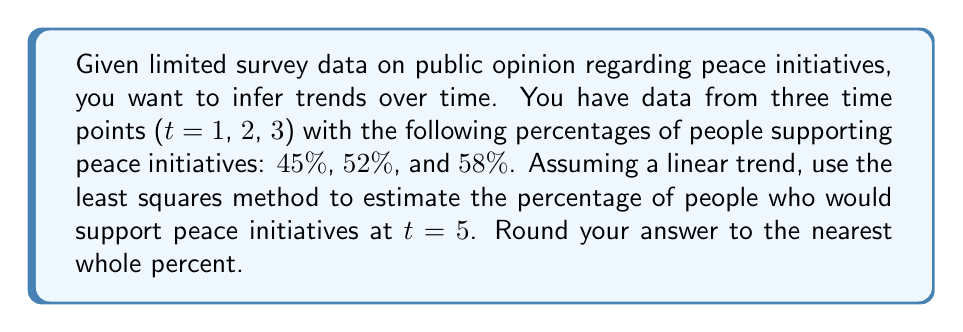Can you answer this question? To solve this inverse problem and infer the trend in public opinion, we'll use the least squares method to fit a linear model to the data.

Step 1: Set up the linear model
Let $y = mx + b$, where:
$y$ is the percentage supporting peace initiatives
$x$ is the time point
$m$ is the slope (rate of change)
$b$ is the y-intercept

Step 2: Create a system of equations
For each data point (x, y):
t=1: $45 = m(1) + b$
t=2: $52 = m(2) + b$
t=3: $58 = m(3) + b$

Step 3: Calculate the means
$\bar{x} = \frac{1 + 2 + 3}{3} = 2$
$\bar{y} = \frac{45 + 52 + 58}{3} = 51.67$

Step 4: Calculate the slope (m)
$$m = \frac{\sum(x_i - \bar{x})(y_i - \bar{y})}{\sum(x_i - \bar{x})^2}$$

$$(1-2)(45-51.67) + (2-2)(52-51.67) + (3-2)(58-51.67)$$
$$-----------------------------------------------------$$
$$(1-2)^2 + (2-2)^2 + (3-2)^2$$

$$= \frac{6.67 + 0 + 6.33}{1 + 0 + 1} = \frac{13}{2} = 6.5$$

Step 5: Calculate the y-intercept (b)
$b = \bar{y} - m\bar{x} = 51.67 - 6.5(2) = 38.67$

Step 6: Use the linear model to estimate y at t=5
$y = 6.5x + 38.67$
$y = 6.5(5) + 38.67 = 71.17$

Step 7: Round to the nearest whole percent
71.17% ≈ 71%
Answer: 71% 